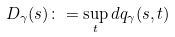<formula> <loc_0><loc_0><loc_500><loc_500>D _ { \gamma } ( s ) \colon = \sup _ { t } d q _ { \gamma } ( s , t )</formula> 